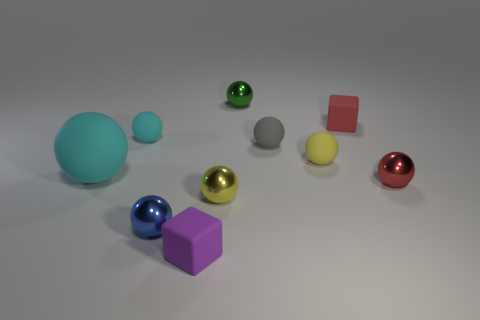Subtract 3 spheres. How many spheres are left? 5 Subtract all big matte spheres. How many spheres are left? 7 Subtract all red spheres. How many spheres are left? 7 Subtract all gray balls. Subtract all cyan cylinders. How many balls are left? 7 Subtract all blocks. How many objects are left? 8 Subtract 0 gray cylinders. How many objects are left? 10 Subtract all large blue objects. Subtract all tiny gray objects. How many objects are left? 9 Add 5 cyan objects. How many cyan objects are left? 7 Add 6 tiny red matte things. How many tiny red matte things exist? 7 